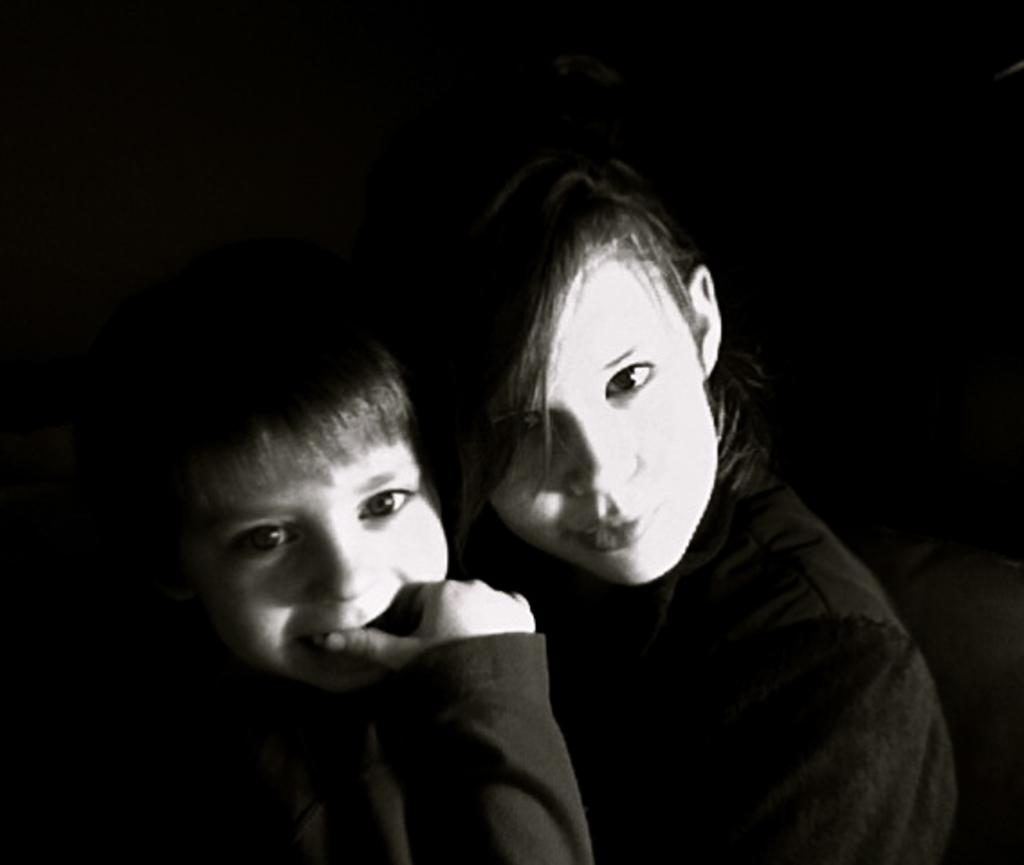What is the color scheme of the image? The image is black and white. Who can be seen in the image? There is a lady and a child in the image. What can be observed in the background of the image? The background of the image is black. What type of headwear is the child wearing in the image? There is no headwear visible on the child in the image. How much salt is present in the image? There is no salt present in the image. 